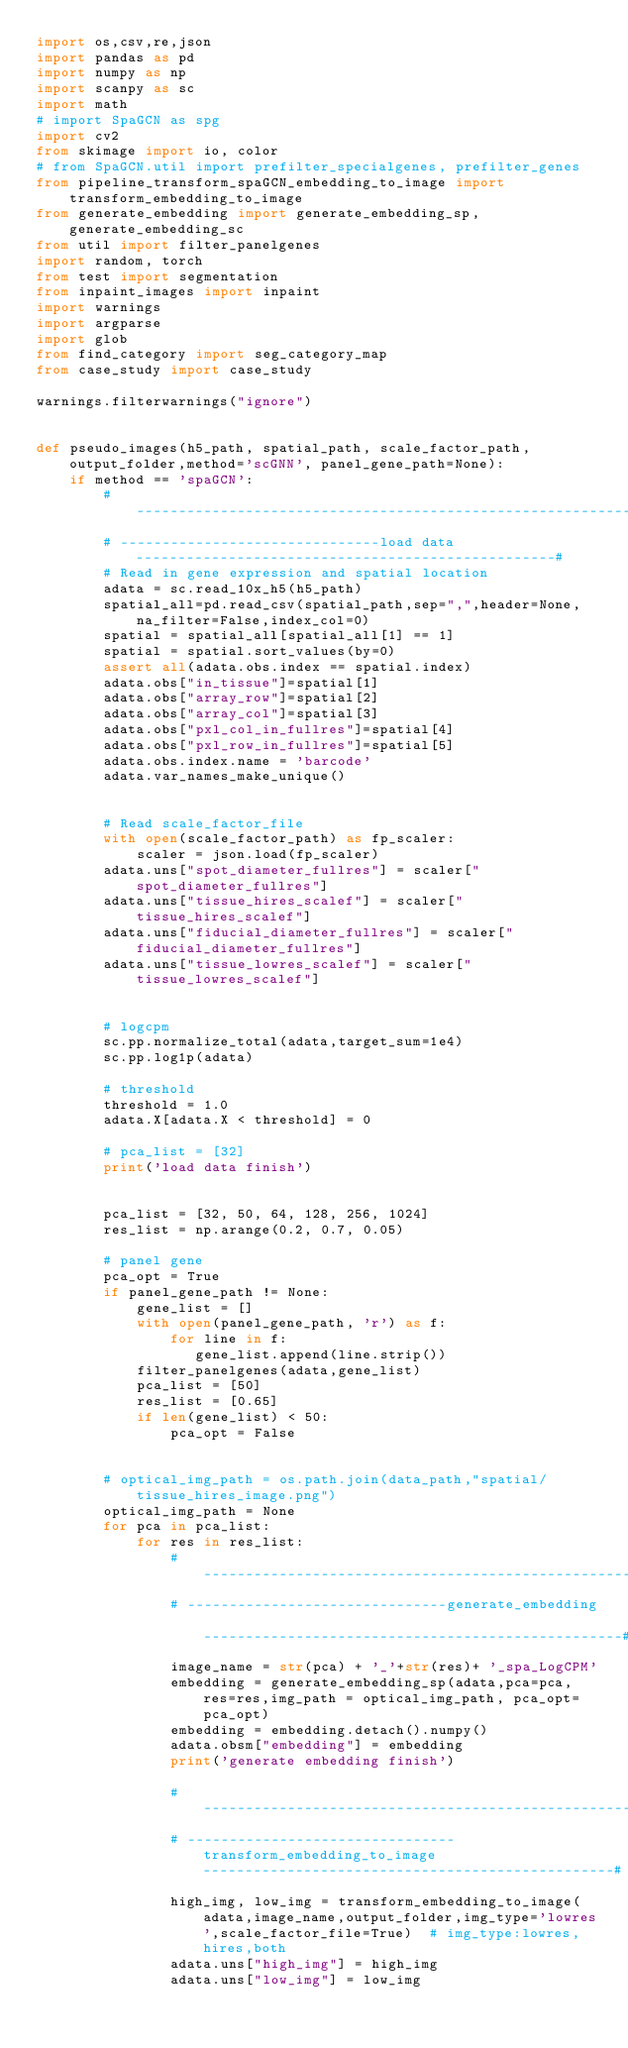Convert code to text. <code><loc_0><loc_0><loc_500><loc_500><_Python_>import os,csv,re,json
import pandas as pd
import numpy as np
import scanpy as sc
import math
# import SpaGCN as spg
import cv2
from skimage import io, color
# from SpaGCN.util import prefilter_specialgenes, prefilter_genes
from pipeline_transform_spaGCN_embedding_to_image import transform_embedding_to_image
from generate_embedding import generate_embedding_sp,generate_embedding_sc
from util import filter_panelgenes
import random, torch
from test import segmentation
from inpaint_images import inpaint
import warnings
import argparse
import glob
from find_category import seg_category_map
from case_study import case_study

warnings.filterwarnings("ignore")


def pseudo_images(h5_path, spatial_path, scale_factor_path, output_folder,method='scGNN', panel_gene_path=None):
    if method == 'spaGCN':
        # --------------------------------------------------------------------------------------------------------#
        # -------------------------------load data--------------------------------------------------#
        # Read in gene expression and spatial location
        adata = sc.read_10x_h5(h5_path)
        spatial_all=pd.read_csv(spatial_path,sep=",",header=None,na_filter=False,index_col=0)
        spatial = spatial_all[spatial_all[1] == 1]
        spatial = spatial.sort_values(by=0)
        assert all(adata.obs.index == spatial.index)
        adata.obs["in_tissue"]=spatial[1]
        adata.obs["array_row"]=spatial[2]
        adata.obs["array_col"]=spatial[3]
        adata.obs["pxl_col_in_fullres"]=spatial[4]
        adata.obs["pxl_row_in_fullres"]=spatial[5]
        adata.obs.index.name = 'barcode'
        adata.var_names_make_unique()


        # Read scale_factor_file
        with open(scale_factor_path) as fp_scaler:
            scaler = json.load(fp_scaler)
        adata.uns["spot_diameter_fullres"] = scaler["spot_diameter_fullres"]
        adata.uns["tissue_hires_scalef"] = scaler["tissue_hires_scalef"]
        adata.uns["fiducial_diameter_fullres"] = scaler["fiducial_diameter_fullres"]
        adata.uns["tissue_lowres_scalef"] = scaler["tissue_lowres_scalef"]


        # logcpm
        sc.pp.normalize_total(adata,target_sum=1e4)
        sc.pp.log1p(adata)

        # threshold
        threshold = 1.0
        adata.X[adata.X < threshold] = 0

        # pca_list = [32]
        print('load data finish')


        pca_list = [32, 50, 64, 128, 256, 1024]
        res_list = np.arange(0.2, 0.7, 0.05)

        # panel gene
        pca_opt = True
        if panel_gene_path != None:
            gene_list = []
            with open(panel_gene_path, 'r') as f:
                for line in f:
                   gene_list.append(line.strip())
            filter_panelgenes(adata,gene_list)
            pca_list = [50]
            res_list = [0.65]
            if len(gene_list) < 50:
                pca_opt = False


        # optical_img_path = os.path.join(data_path,"spatial/tissue_hires_image.png")
        optical_img_path = None
        for pca in pca_list:
            for res in res_list:
                # --------------------------------------------------------------------------------------------------------#
                # -------------------------------generate_embedding --------------------------------------------------#
                image_name = str(pca) + '_'+str(res)+ '_spa_LogCPM'
                embedding = generate_embedding_sp(adata,pca=pca, res=res,img_path = optical_img_path, pca_opt=pca_opt)
                embedding = embedding.detach().numpy()
                adata.obsm["embedding"] = embedding
                print('generate embedding finish')

                # --------------------------------------------------------------------------------------------------------#
                # --------------------------------transform_embedding_to_image-------------------------------------------------#
                high_img, low_img = transform_embedding_to_image(adata,image_name,output_folder,img_type='lowres',scale_factor_file=True)  # img_type:lowres,hires,both
                adata.uns["high_img"] = high_img
                adata.uns["low_img"] = low_img</code> 